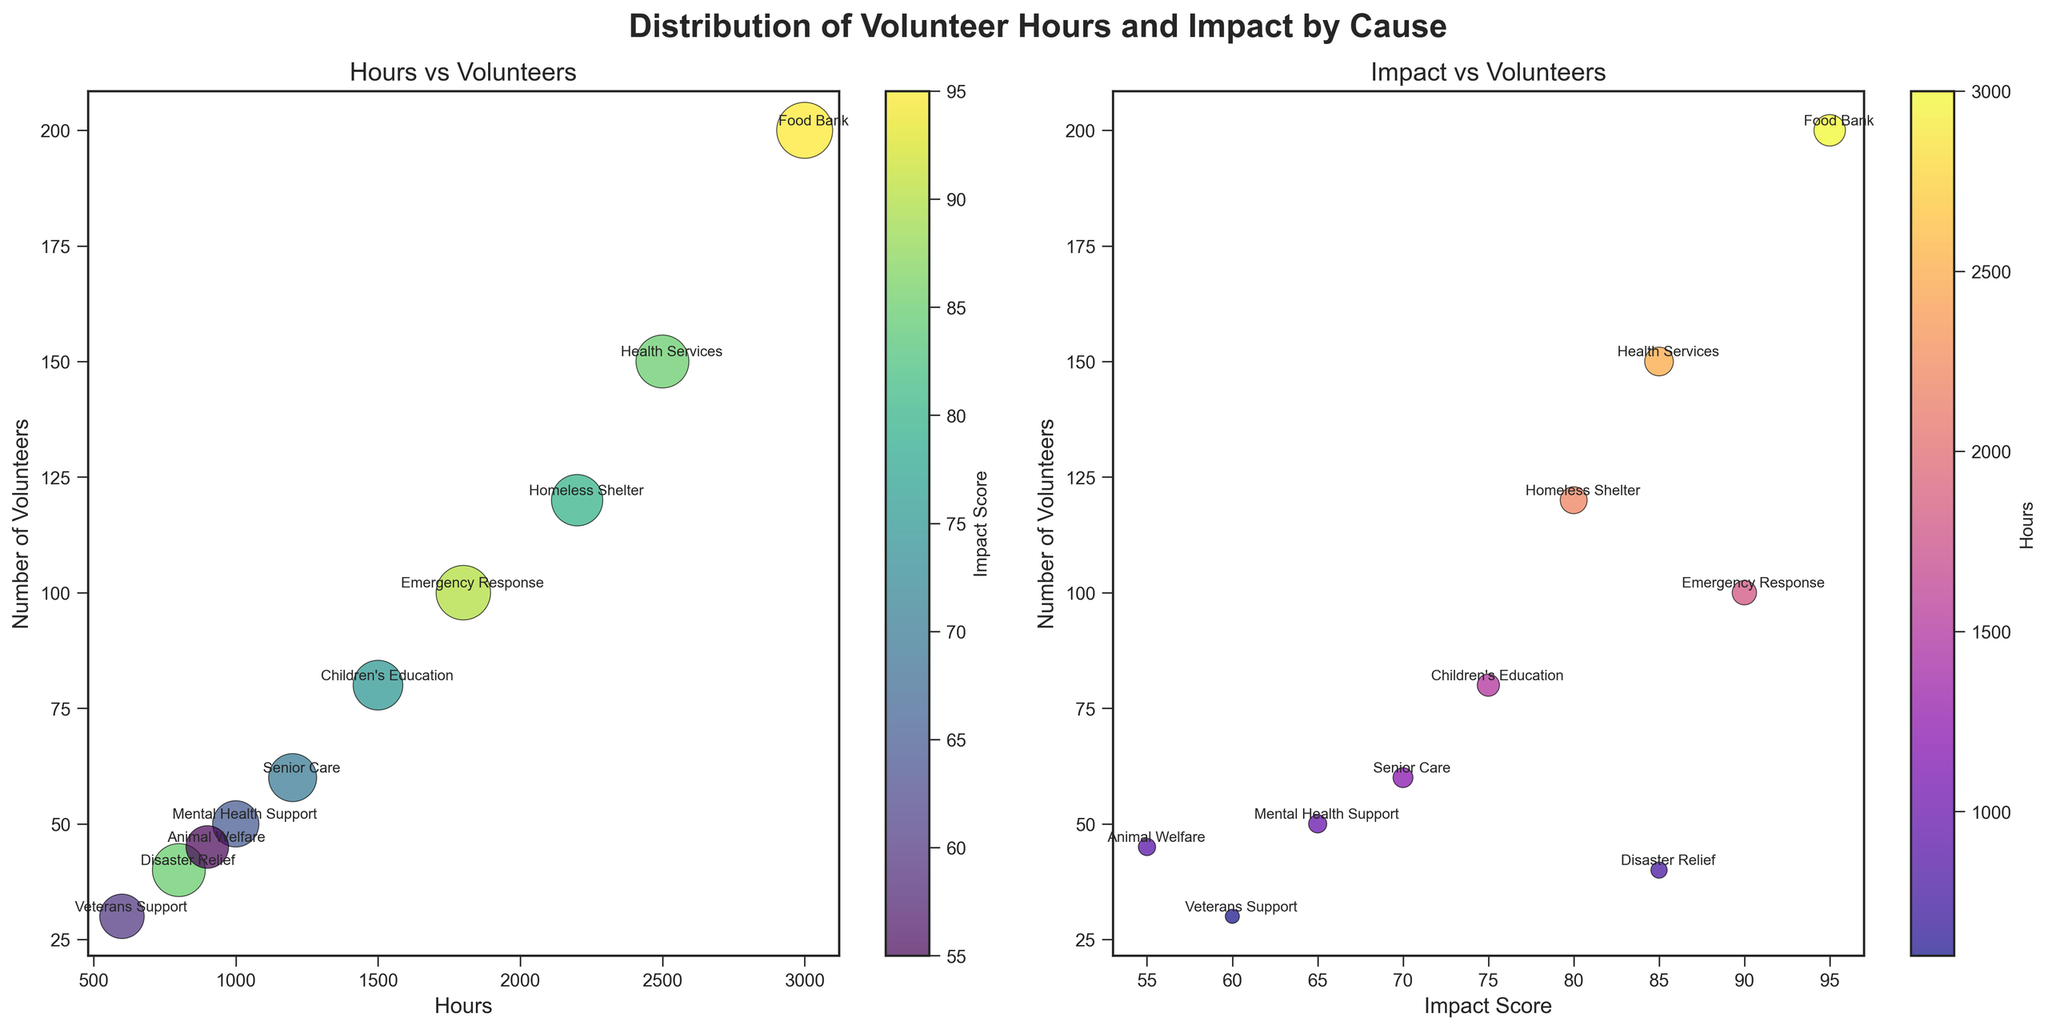What is the title of the figure? The title is usually positioned at the top of the figure. It is written in a bold font and larger size relative to other text elements in the plot. The title of the figure is "Distribution of Volunteer Hours and Impact by Cause".
Answer: Distribution of Volunteer Hours and Impact by Cause How many causes are represented in the plots? To determine the number of causes, count the number of unique data points annotated with different causes on either of the subplots. There are 10 unique data points (causes) labeled on the plots.
Answer: 10 Which cause has the highest number of volunteer hours? Look for the data point farthest along the x-axis representing "Hours" in the first subplot (Hours vs Volunteers). The Food Bank is positioned farthest to the right on the x-axis with 3000 hours.
Answer: Food Bank Which subplot uses 'Impact Score' as a color scale? In the two subplots, check the color bar labels. The first subplot (Hours vs Volunteers) has a color bar labeled 'Impact Score'.
Answer: The first subplot (Hours vs Volunteers) Which cause has the smallest bubble size in the 'Impact vs Volunteers' plot? Bubble size in the 'Impact vs Volunteers' plot represents 'Hours'. The smallest bubble corresponds to the smallest number of hours, which is Veterans Support with 600 hours.
Answer: Veterans Support What is the number of volunteers for Mental Health Support? In either subplot, locate the data point labeled "Mental Health Support" and look at the value on the vertical axis. Mental Health Support has 50 volunteers.
Answer: 50 Compare the volunteer count between Health Services and Food Bank. Which has more volunteers? In either subplot, compare the y-axis positions of the points labeled "Health Services" and "Food Bank". The Food Bank is positioned higher on the y-axis indicating 200 volunteers, whereas Health Services has 150 volunteers.
Answer: Food Bank What's the difference in impact scores between Homeless Shelter and Children's Education? In either subplot, find the horizontal axis values for "Homeless Shelter" (80) and "Children's Education" (75). The difference is 80 - 75 = 5.
Answer: 5 How does the number of volunteers vary when moving from groups with low impact scores to high impact scores in the 'Impact vs Volunteers' plot? Observe the general pattern of data points in the second subplot (Impact vs Volunteers). As the impact score increases along the x-axis, the corresponding y-axis values (volunteers) show a varied pattern without a consistent trend; thus, variability exists.
Answer: Variable Which cause has an equal number of volunteers and impact score? In the 'Impact vs Volunteers' plot, look for a data point where the x and y values (Impact Score and Number of Volunteers) are equal. No data point shows an equal number of volunteers and impact score.
Answer: None 